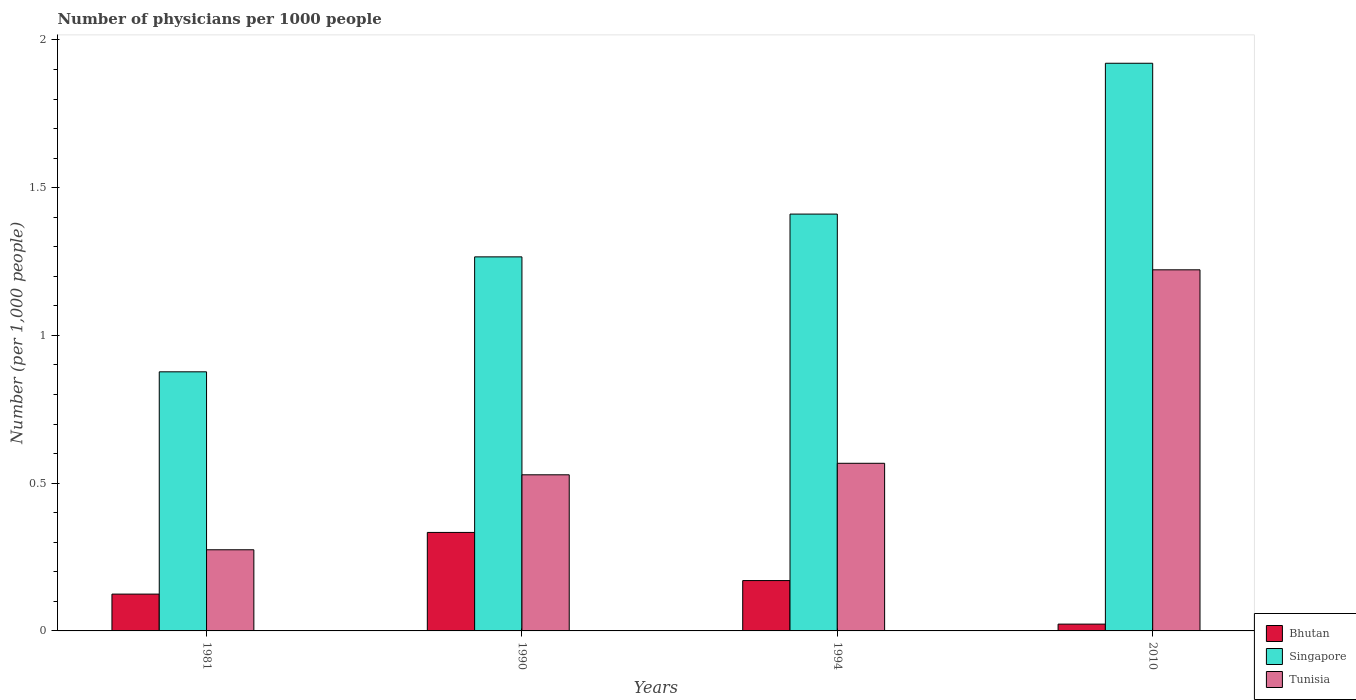How many groups of bars are there?
Provide a succinct answer. 4. How many bars are there on the 3rd tick from the left?
Your answer should be very brief. 3. In how many cases, is the number of bars for a given year not equal to the number of legend labels?
Ensure brevity in your answer.  0. What is the number of physicians in Bhutan in 2010?
Your answer should be compact. 0.02. Across all years, what is the maximum number of physicians in Bhutan?
Make the answer very short. 0.33. Across all years, what is the minimum number of physicians in Singapore?
Your answer should be very brief. 0.88. What is the total number of physicians in Bhutan in the graph?
Your response must be concise. 0.65. What is the difference between the number of physicians in Singapore in 1990 and that in 2010?
Your answer should be compact. -0.66. What is the difference between the number of physicians in Tunisia in 1981 and the number of physicians in Bhutan in 1990?
Offer a terse response. -0.06. What is the average number of physicians in Singapore per year?
Offer a terse response. 1.37. In the year 1994, what is the difference between the number of physicians in Bhutan and number of physicians in Tunisia?
Provide a succinct answer. -0.4. In how many years, is the number of physicians in Bhutan greater than 1.3?
Offer a terse response. 0. What is the ratio of the number of physicians in Tunisia in 1981 to that in 2010?
Make the answer very short. 0.22. Is the number of physicians in Singapore in 1981 less than that in 1990?
Offer a very short reply. Yes. Is the difference between the number of physicians in Bhutan in 1990 and 2010 greater than the difference between the number of physicians in Tunisia in 1990 and 2010?
Make the answer very short. Yes. What is the difference between the highest and the second highest number of physicians in Tunisia?
Provide a short and direct response. 0.65. What is the difference between the highest and the lowest number of physicians in Tunisia?
Ensure brevity in your answer.  0.95. What does the 1st bar from the left in 1990 represents?
Ensure brevity in your answer.  Bhutan. What does the 2nd bar from the right in 1994 represents?
Provide a succinct answer. Singapore. Is it the case that in every year, the sum of the number of physicians in Tunisia and number of physicians in Bhutan is greater than the number of physicians in Singapore?
Provide a succinct answer. No. What is the difference between two consecutive major ticks on the Y-axis?
Provide a succinct answer. 0.5. Are the values on the major ticks of Y-axis written in scientific E-notation?
Provide a succinct answer. No. Does the graph contain any zero values?
Offer a terse response. No. What is the title of the graph?
Your answer should be compact. Number of physicians per 1000 people. What is the label or title of the X-axis?
Make the answer very short. Years. What is the label or title of the Y-axis?
Your answer should be compact. Number (per 1,0 people). What is the Number (per 1,000 people) of Bhutan in 1981?
Your answer should be very brief. 0.12. What is the Number (per 1,000 people) of Singapore in 1981?
Make the answer very short. 0.88. What is the Number (per 1,000 people) of Tunisia in 1981?
Offer a terse response. 0.27. What is the Number (per 1,000 people) of Bhutan in 1990?
Provide a succinct answer. 0.33. What is the Number (per 1,000 people) in Singapore in 1990?
Your answer should be compact. 1.27. What is the Number (per 1,000 people) of Tunisia in 1990?
Your answer should be compact. 0.53. What is the Number (per 1,000 people) in Bhutan in 1994?
Ensure brevity in your answer.  0.17. What is the Number (per 1,000 people) in Singapore in 1994?
Give a very brief answer. 1.41. What is the Number (per 1,000 people) in Tunisia in 1994?
Give a very brief answer. 0.57. What is the Number (per 1,000 people) of Bhutan in 2010?
Keep it short and to the point. 0.02. What is the Number (per 1,000 people) of Singapore in 2010?
Your answer should be compact. 1.92. What is the Number (per 1,000 people) of Tunisia in 2010?
Your answer should be compact. 1.22. Across all years, what is the maximum Number (per 1,000 people) of Bhutan?
Offer a terse response. 0.33. Across all years, what is the maximum Number (per 1,000 people) of Singapore?
Give a very brief answer. 1.92. Across all years, what is the maximum Number (per 1,000 people) in Tunisia?
Give a very brief answer. 1.22. Across all years, what is the minimum Number (per 1,000 people) of Bhutan?
Your answer should be very brief. 0.02. Across all years, what is the minimum Number (per 1,000 people) in Singapore?
Provide a succinct answer. 0.88. Across all years, what is the minimum Number (per 1,000 people) in Tunisia?
Make the answer very short. 0.27. What is the total Number (per 1,000 people) in Bhutan in the graph?
Your answer should be compact. 0.65. What is the total Number (per 1,000 people) in Singapore in the graph?
Offer a very short reply. 5.47. What is the total Number (per 1,000 people) of Tunisia in the graph?
Ensure brevity in your answer.  2.59. What is the difference between the Number (per 1,000 people) of Bhutan in 1981 and that in 1990?
Offer a very short reply. -0.21. What is the difference between the Number (per 1,000 people) of Singapore in 1981 and that in 1990?
Keep it short and to the point. -0.39. What is the difference between the Number (per 1,000 people) in Tunisia in 1981 and that in 1990?
Your answer should be very brief. -0.25. What is the difference between the Number (per 1,000 people) in Bhutan in 1981 and that in 1994?
Your answer should be compact. -0.05. What is the difference between the Number (per 1,000 people) in Singapore in 1981 and that in 1994?
Give a very brief answer. -0.53. What is the difference between the Number (per 1,000 people) of Tunisia in 1981 and that in 1994?
Make the answer very short. -0.29. What is the difference between the Number (per 1,000 people) in Bhutan in 1981 and that in 2010?
Keep it short and to the point. 0.1. What is the difference between the Number (per 1,000 people) of Singapore in 1981 and that in 2010?
Provide a succinct answer. -1.04. What is the difference between the Number (per 1,000 people) of Tunisia in 1981 and that in 2010?
Ensure brevity in your answer.  -0.95. What is the difference between the Number (per 1,000 people) in Bhutan in 1990 and that in 1994?
Your answer should be very brief. 0.16. What is the difference between the Number (per 1,000 people) of Singapore in 1990 and that in 1994?
Make the answer very short. -0.14. What is the difference between the Number (per 1,000 people) in Tunisia in 1990 and that in 1994?
Provide a short and direct response. -0.04. What is the difference between the Number (per 1,000 people) in Bhutan in 1990 and that in 2010?
Give a very brief answer. 0.31. What is the difference between the Number (per 1,000 people) in Singapore in 1990 and that in 2010?
Your answer should be compact. -0.66. What is the difference between the Number (per 1,000 people) of Tunisia in 1990 and that in 2010?
Your response must be concise. -0.69. What is the difference between the Number (per 1,000 people) of Bhutan in 1994 and that in 2010?
Provide a short and direct response. 0.15. What is the difference between the Number (per 1,000 people) in Singapore in 1994 and that in 2010?
Your answer should be very brief. -0.51. What is the difference between the Number (per 1,000 people) of Tunisia in 1994 and that in 2010?
Your response must be concise. -0.65. What is the difference between the Number (per 1,000 people) in Bhutan in 1981 and the Number (per 1,000 people) in Singapore in 1990?
Provide a succinct answer. -1.14. What is the difference between the Number (per 1,000 people) of Bhutan in 1981 and the Number (per 1,000 people) of Tunisia in 1990?
Your response must be concise. -0.4. What is the difference between the Number (per 1,000 people) in Singapore in 1981 and the Number (per 1,000 people) in Tunisia in 1990?
Offer a very short reply. 0.35. What is the difference between the Number (per 1,000 people) in Bhutan in 1981 and the Number (per 1,000 people) in Singapore in 1994?
Offer a very short reply. -1.29. What is the difference between the Number (per 1,000 people) of Bhutan in 1981 and the Number (per 1,000 people) of Tunisia in 1994?
Offer a very short reply. -0.44. What is the difference between the Number (per 1,000 people) in Singapore in 1981 and the Number (per 1,000 people) in Tunisia in 1994?
Give a very brief answer. 0.31. What is the difference between the Number (per 1,000 people) of Bhutan in 1981 and the Number (per 1,000 people) of Singapore in 2010?
Your response must be concise. -1.8. What is the difference between the Number (per 1,000 people) in Bhutan in 1981 and the Number (per 1,000 people) in Tunisia in 2010?
Offer a terse response. -1.1. What is the difference between the Number (per 1,000 people) of Singapore in 1981 and the Number (per 1,000 people) of Tunisia in 2010?
Your answer should be compact. -0.35. What is the difference between the Number (per 1,000 people) of Bhutan in 1990 and the Number (per 1,000 people) of Singapore in 1994?
Ensure brevity in your answer.  -1.08. What is the difference between the Number (per 1,000 people) in Bhutan in 1990 and the Number (per 1,000 people) in Tunisia in 1994?
Offer a terse response. -0.23. What is the difference between the Number (per 1,000 people) of Singapore in 1990 and the Number (per 1,000 people) of Tunisia in 1994?
Give a very brief answer. 0.7. What is the difference between the Number (per 1,000 people) in Bhutan in 1990 and the Number (per 1,000 people) in Singapore in 2010?
Make the answer very short. -1.59. What is the difference between the Number (per 1,000 people) of Bhutan in 1990 and the Number (per 1,000 people) of Tunisia in 2010?
Keep it short and to the point. -0.89. What is the difference between the Number (per 1,000 people) of Singapore in 1990 and the Number (per 1,000 people) of Tunisia in 2010?
Your answer should be compact. 0.04. What is the difference between the Number (per 1,000 people) of Bhutan in 1994 and the Number (per 1,000 people) of Singapore in 2010?
Your response must be concise. -1.75. What is the difference between the Number (per 1,000 people) in Bhutan in 1994 and the Number (per 1,000 people) in Tunisia in 2010?
Ensure brevity in your answer.  -1.05. What is the difference between the Number (per 1,000 people) in Singapore in 1994 and the Number (per 1,000 people) in Tunisia in 2010?
Give a very brief answer. 0.19. What is the average Number (per 1,000 people) of Bhutan per year?
Keep it short and to the point. 0.16. What is the average Number (per 1,000 people) in Singapore per year?
Make the answer very short. 1.37. What is the average Number (per 1,000 people) of Tunisia per year?
Ensure brevity in your answer.  0.65. In the year 1981, what is the difference between the Number (per 1,000 people) of Bhutan and Number (per 1,000 people) of Singapore?
Provide a short and direct response. -0.75. In the year 1981, what is the difference between the Number (per 1,000 people) of Singapore and Number (per 1,000 people) of Tunisia?
Make the answer very short. 0.6. In the year 1990, what is the difference between the Number (per 1,000 people) in Bhutan and Number (per 1,000 people) in Singapore?
Offer a very short reply. -0.93. In the year 1990, what is the difference between the Number (per 1,000 people) of Bhutan and Number (per 1,000 people) of Tunisia?
Give a very brief answer. -0.2. In the year 1990, what is the difference between the Number (per 1,000 people) of Singapore and Number (per 1,000 people) of Tunisia?
Offer a terse response. 0.74. In the year 1994, what is the difference between the Number (per 1,000 people) in Bhutan and Number (per 1,000 people) in Singapore?
Offer a very short reply. -1.24. In the year 1994, what is the difference between the Number (per 1,000 people) in Bhutan and Number (per 1,000 people) in Tunisia?
Keep it short and to the point. -0.4. In the year 1994, what is the difference between the Number (per 1,000 people) in Singapore and Number (per 1,000 people) in Tunisia?
Your answer should be compact. 0.84. In the year 2010, what is the difference between the Number (per 1,000 people) of Bhutan and Number (per 1,000 people) of Singapore?
Give a very brief answer. -1.9. In the year 2010, what is the difference between the Number (per 1,000 people) of Bhutan and Number (per 1,000 people) of Tunisia?
Your response must be concise. -1.2. In the year 2010, what is the difference between the Number (per 1,000 people) in Singapore and Number (per 1,000 people) in Tunisia?
Your answer should be compact. 0.7. What is the ratio of the Number (per 1,000 people) of Bhutan in 1981 to that in 1990?
Your answer should be very brief. 0.37. What is the ratio of the Number (per 1,000 people) in Singapore in 1981 to that in 1990?
Offer a very short reply. 0.69. What is the ratio of the Number (per 1,000 people) of Tunisia in 1981 to that in 1990?
Offer a very short reply. 0.52. What is the ratio of the Number (per 1,000 people) in Bhutan in 1981 to that in 1994?
Your answer should be very brief. 0.73. What is the ratio of the Number (per 1,000 people) of Singapore in 1981 to that in 1994?
Keep it short and to the point. 0.62. What is the ratio of the Number (per 1,000 people) of Tunisia in 1981 to that in 1994?
Give a very brief answer. 0.48. What is the ratio of the Number (per 1,000 people) in Bhutan in 1981 to that in 2010?
Provide a short and direct response. 5.42. What is the ratio of the Number (per 1,000 people) of Singapore in 1981 to that in 2010?
Your answer should be compact. 0.46. What is the ratio of the Number (per 1,000 people) of Tunisia in 1981 to that in 2010?
Keep it short and to the point. 0.22. What is the ratio of the Number (per 1,000 people) in Bhutan in 1990 to that in 1994?
Keep it short and to the point. 1.96. What is the ratio of the Number (per 1,000 people) of Singapore in 1990 to that in 1994?
Provide a short and direct response. 0.9. What is the ratio of the Number (per 1,000 people) of Tunisia in 1990 to that in 1994?
Offer a terse response. 0.93. What is the ratio of the Number (per 1,000 people) in Bhutan in 1990 to that in 2010?
Provide a succinct answer. 14.49. What is the ratio of the Number (per 1,000 people) of Singapore in 1990 to that in 2010?
Provide a succinct answer. 0.66. What is the ratio of the Number (per 1,000 people) in Tunisia in 1990 to that in 2010?
Provide a succinct answer. 0.43. What is the ratio of the Number (per 1,000 people) of Bhutan in 1994 to that in 2010?
Ensure brevity in your answer.  7.41. What is the ratio of the Number (per 1,000 people) of Singapore in 1994 to that in 2010?
Ensure brevity in your answer.  0.73. What is the ratio of the Number (per 1,000 people) in Tunisia in 1994 to that in 2010?
Ensure brevity in your answer.  0.46. What is the difference between the highest and the second highest Number (per 1,000 people) of Bhutan?
Give a very brief answer. 0.16. What is the difference between the highest and the second highest Number (per 1,000 people) in Singapore?
Your answer should be compact. 0.51. What is the difference between the highest and the second highest Number (per 1,000 people) of Tunisia?
Provide a succinct answer. 0.65. What is the difference between the highest and the lowest Number (per 1,000 people) in Bhutan?
Keep it short and to the point. 0.31. What is the difference between the highest and the lowest Number (per 1,000 people) in Singapore?
Provide a succinct answer. 1.04. What is the difference between the highest and the lowest Number (per 1,000 people) of Tunisia?
Give a very brief answer. 0.95. 